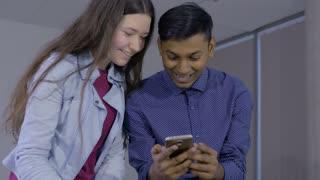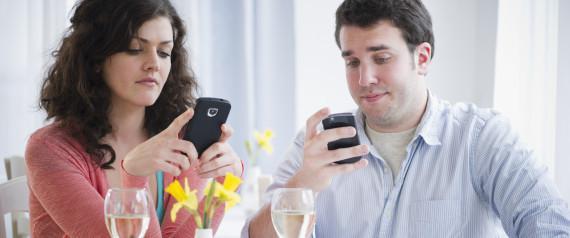The first image is the image on the left, the second image is the image on the right. Assess this claim about the two images: "There are at most five people in the image pair.". Correct or not? Answer yes or no. Yes. The first image is the image on the left, the second image is the image on the right. For the images displayed, is the sentence "The right image contains no more than three humans holding cell phones." factually correct? Answer yes or no. Yes. 